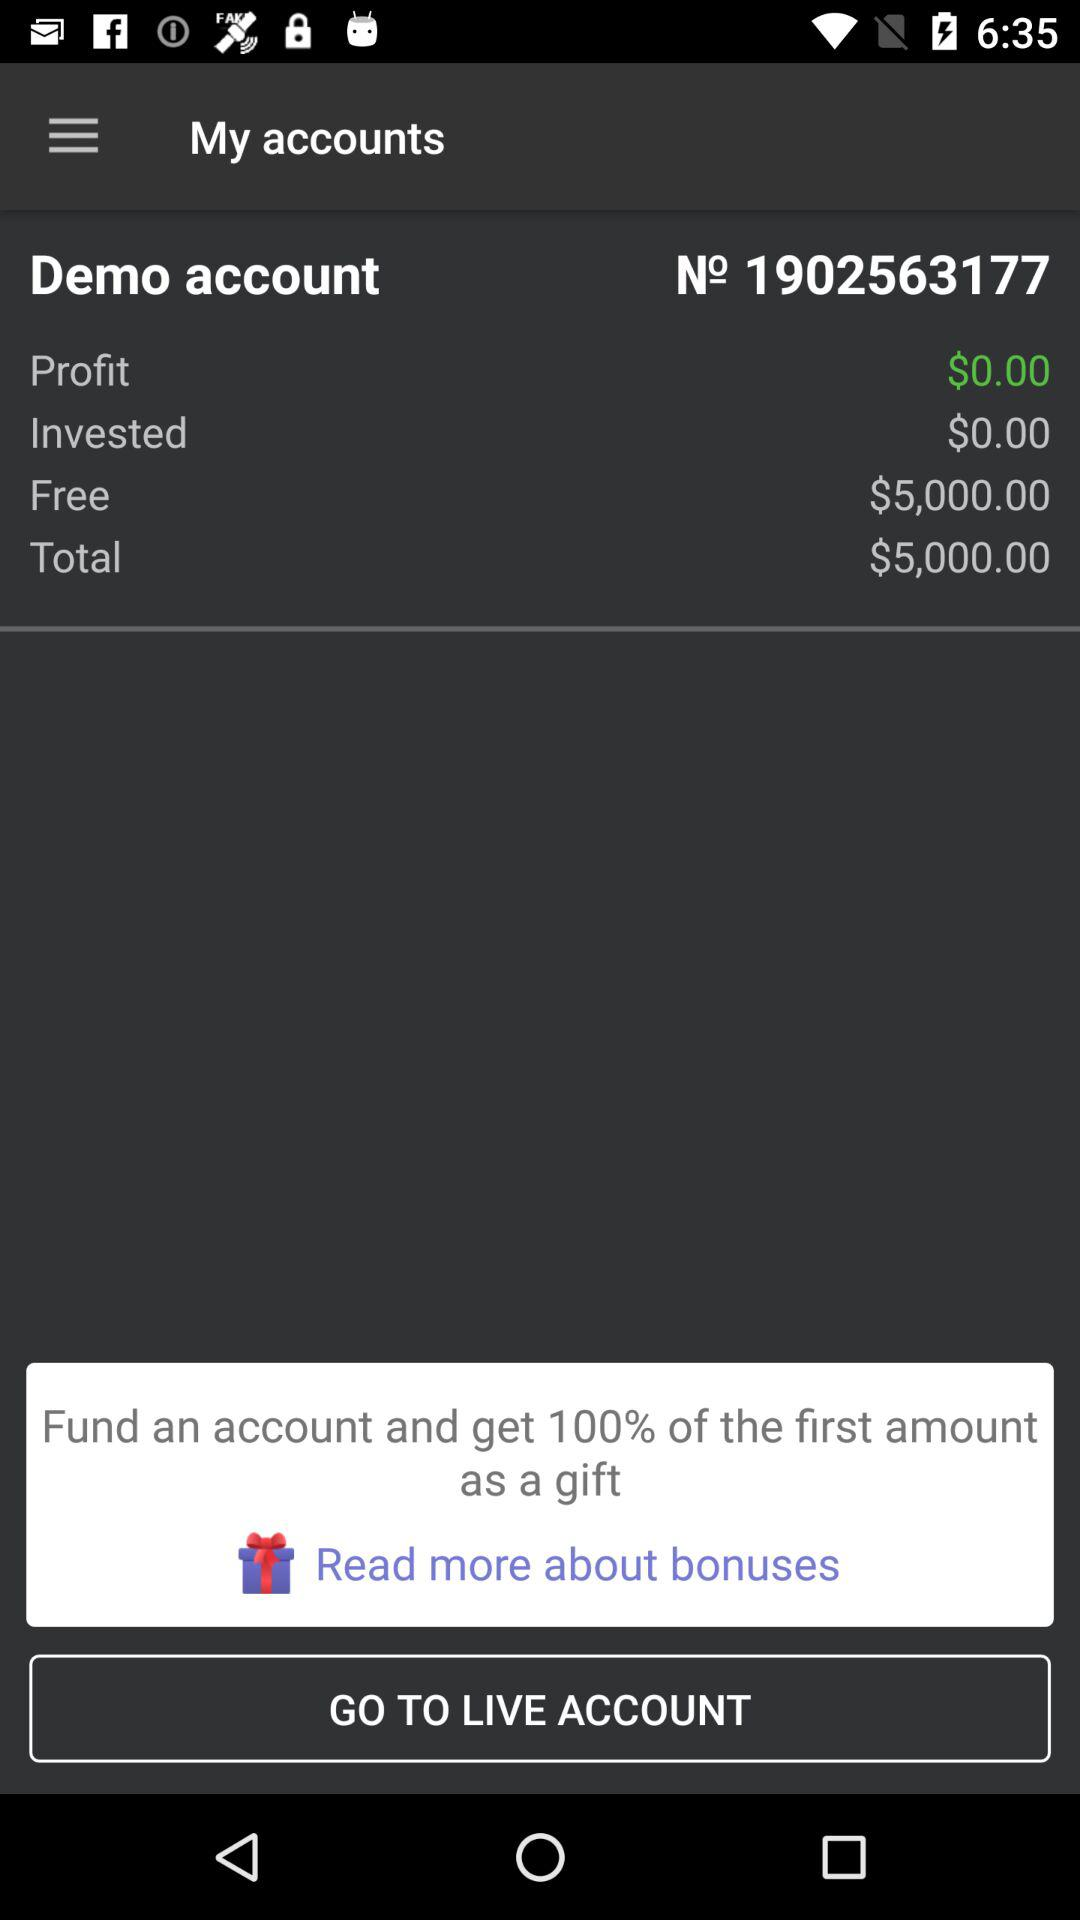What is the total amount? The total amount is $5,000. 